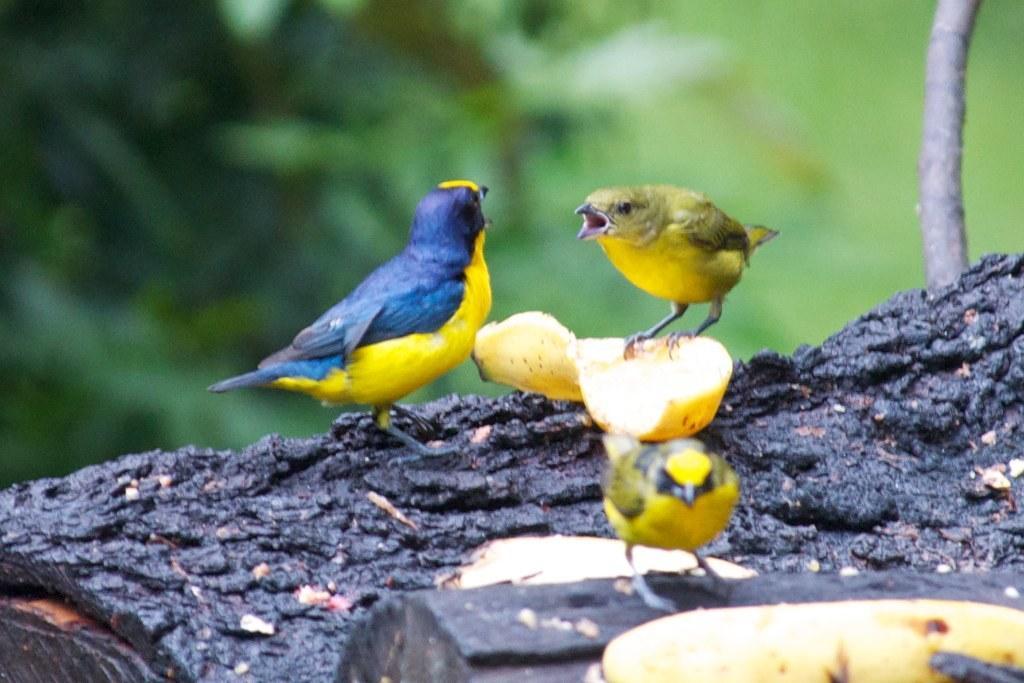In one or two sentences, can you explain what this image depicts? In this image there are birds standing on a tree trunk. There is a bird standing on a banana peel. In the bottom right there is a banana. The background is blurry. 